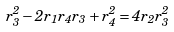Convert formula to latex. <formula><loc_0><loc_0><loc_500><loc_500>r _ { 3 } ^ { 2 } - 2 r _ { 1 } r _ { 4 } r _ { 3 } + r _ { 4 } ^ { 2 } = 4 r _ { 2 } r _ { 3 } ^ { 2 }</formula> 